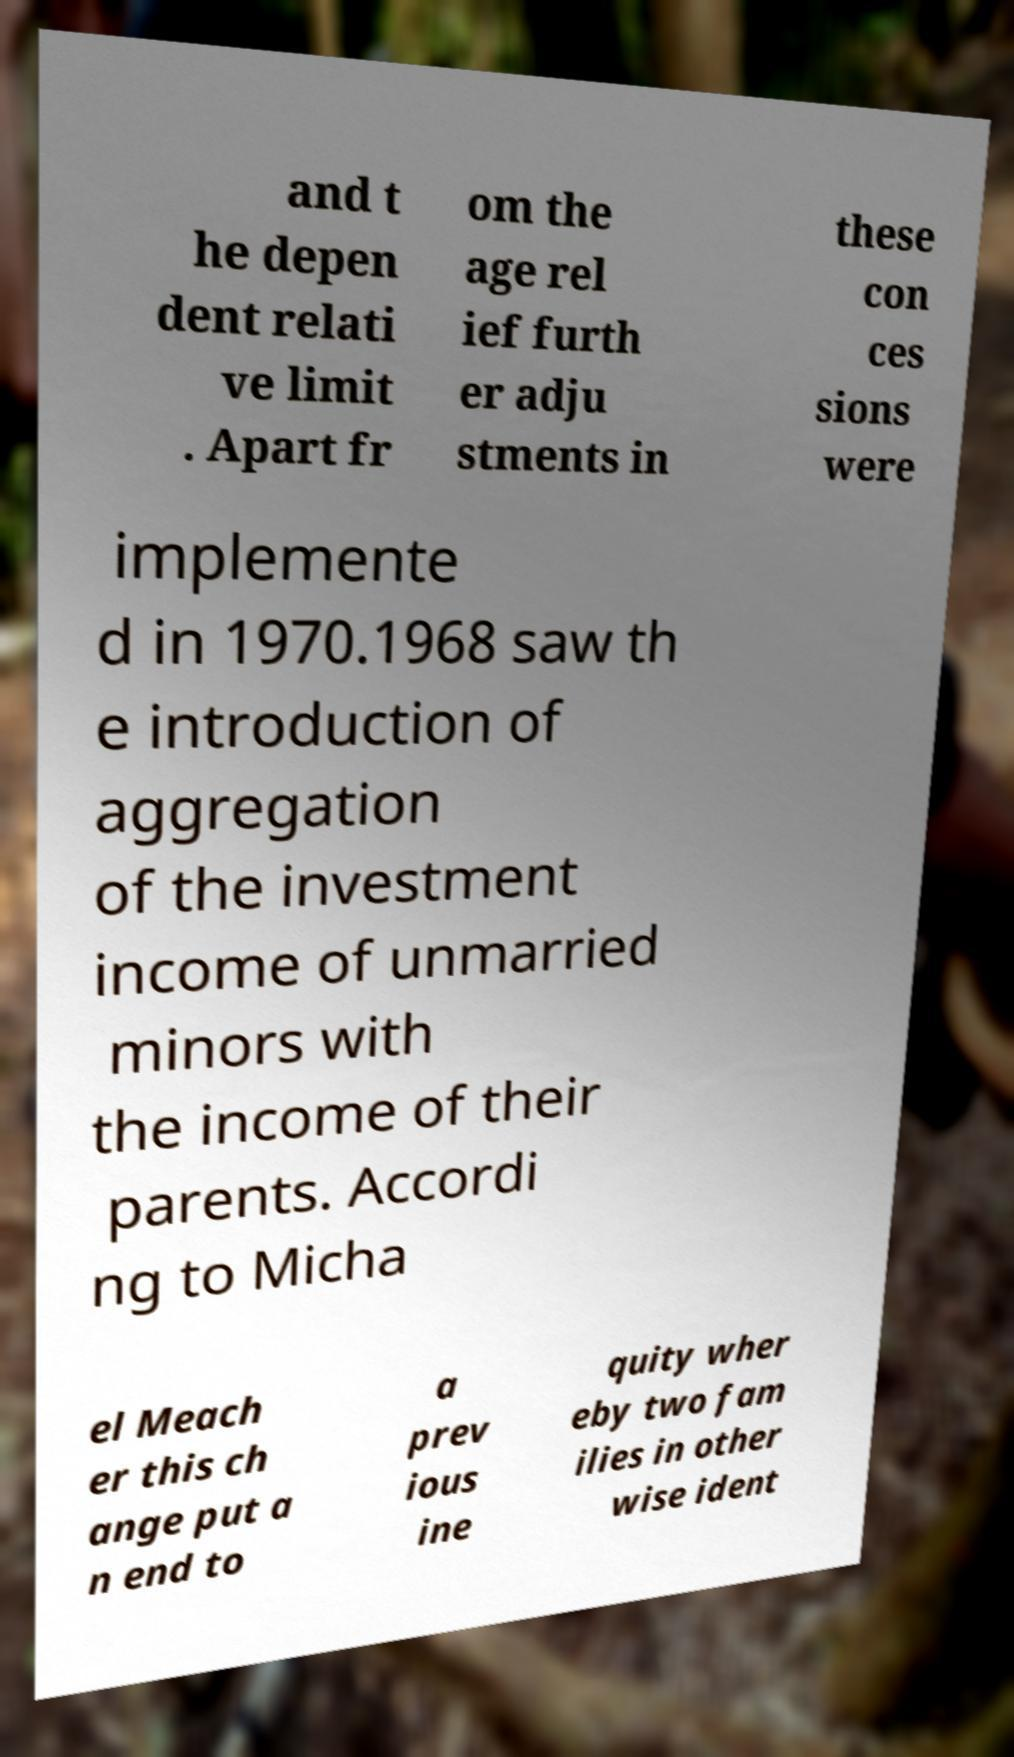Please identify and transcribe the text found in this image. and t he depen dent relati ve limit . Apart fr om the age rel ief furth er adju stments in these con ces sions were implemente d in 1970.1968 saw th e introduction of aggregation of the investment income of unmarried minors with the income of their parents. Accordi ng to Micha el Meach er this ch ange put a n end to a prev ious ine quity wher eby two fam ilies in other wise ident 